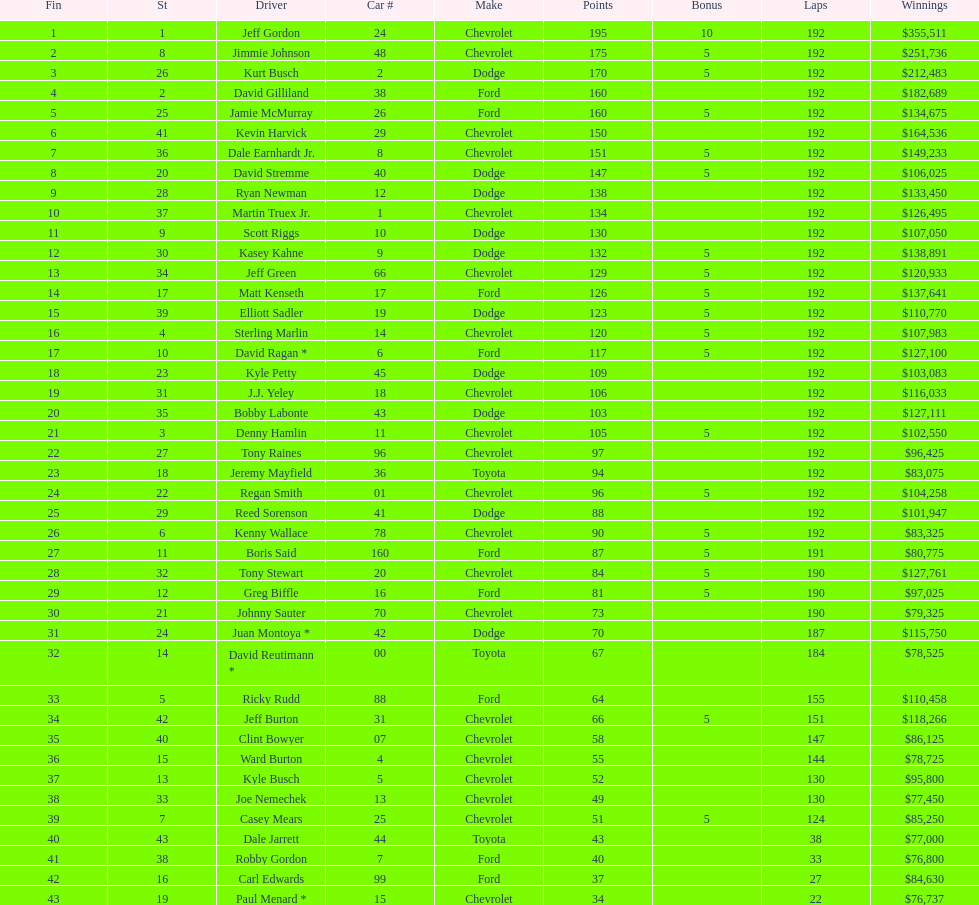What type of race car was driven by both jeff gordon and jimmie johnson? Chevrolet. 